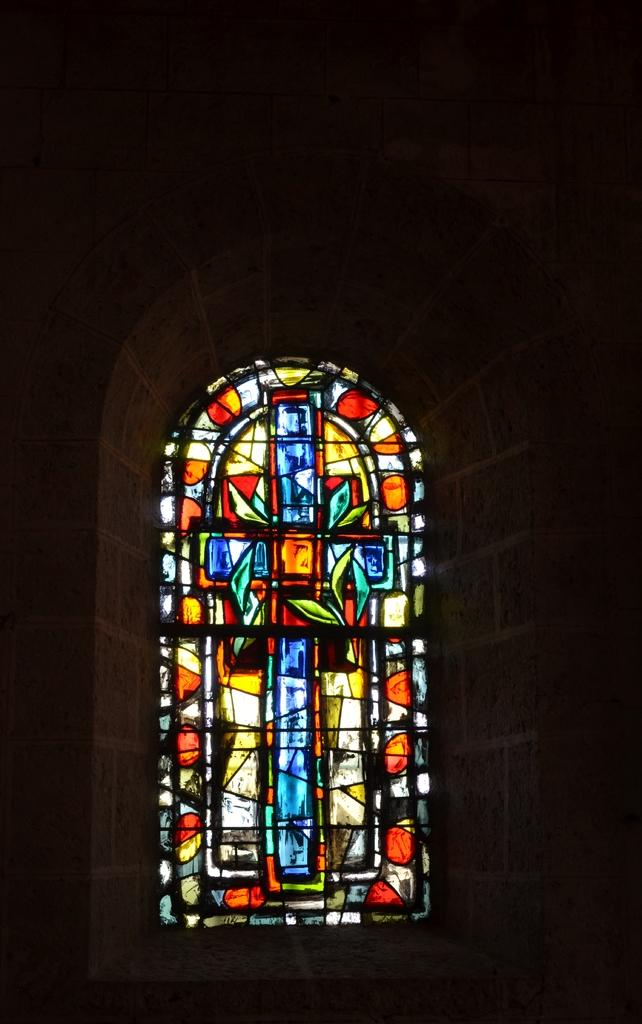What can be seen in the image that has a colorful design? There is a colorful window in the image. What else is visible in the image besides the window? There is a wall visible in the image. What key is being used to unlock the door in the image? There is no door or key present in the image; it only features a colorful window and a wall. 